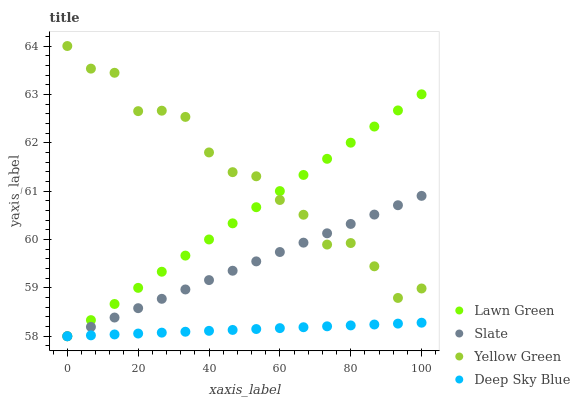Does Deep Sky Blue have the minimum area under the curve?
Answer yes or no. Yes. Does Yellow Green have the maximum area under the curve?
Answer yes or no. Yes. Does Slate have the minimum area under the curve?
Answer yes or no. No. Does Slate have the maximum area under the curve?
Answer yes or no. No. Is Slate the smoothest?
Answer yes or no. Yes. Is Yellow Green the roughest?
Answer yes or no. Yes. Is Yellow Green the smoothest?
Answer yes or no. No. Is Slate the roughest?
Answer yes or no. No. Does Lawn Green have the lowest value?
Answer yes or no. Yes. Does Yellow Green have the lowest value?
Answer yes or no. No. Does Yellow Green have the highest value?
Answer yes or no. Yes. Does Slate have the highest value?
Answer yes or no. No. Is Deep Sky Blue less than Yellow Green?
Answer yes or no. Yes. Is Yellow Green greater than Deep Sky Blue?
Answer yes or no. Yes. Does Slate intersect Lawn Green?
Answer yes or no. Yes. Is Slate less than Lawn Green?
Answer yes or no. No. Is Slate greater than Lawn Green?
Answer yes or no. No. Does Deep Sky Blue intersect Yellow Green?
Answer yes or no. No. 